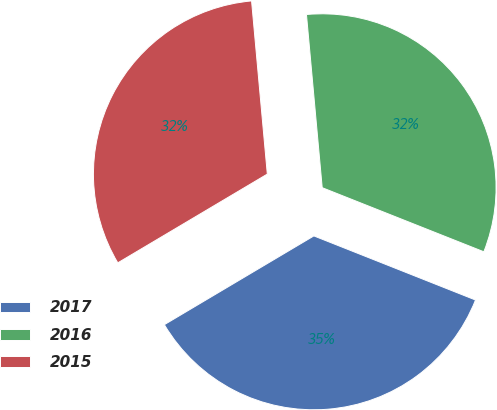<chart> <loc_0><loc_0><loc_500><loc_500><pie_chart><fcel>2017<fcel>2016<fcel>2015<nl><fcel>35.46%<fcel>32.45%<fcel>32.08%<nl></chart> 